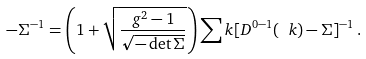Convert formula to latex. <formula><loc_0><loc_0><loc_500><loc_500>- \Sigma ^ { - 1 } = \left ( 1 + \sqrt { \frac { g ^ { 2 } - 1 } { \sqrt { - \det \Sigma } } } \right ) \sum _ { \ } k [ D ^ { 0 - 1 } ( \ k ) - \Sigma ] ^ { - 1 } \, .</formula> 